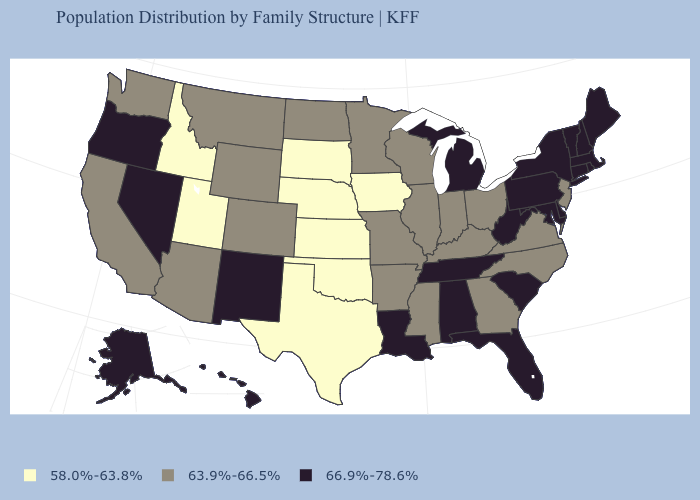Does New Hampshire have a higher value than North Carolina?
Keep it brief. Yes. Which states have the lowest value in the West?
Quick response, please. Idaho, Utah. What is the value of Utah?
Keep it brief. 58.0%-63.8%. What is the value of Maryland?
Write a very short answer. 66.9%-78.6%. What is the value of Arizona?
Write a very short answer. 63.9%-66.5%. Does Florida have the same value as Rhode Island?
Concise answer only. Yes. What is the value of Texas?
Keep it brief. 58.0%-63.8%. Does the first symbol in the legend represent the smallest category?
Short answer required. Yes. What is the highest value in the USA?
Be succinct. 66.9%-78.6%. Which states have the lowest value in the South?
Be succinct. Oklahoma, Texas. What is the lowest value in the Northeast?
Short answer required. 63.9%-66.5%. Does the first symbol in the legend represent the smallest category?
Be succinct. Yes. Name the states that have a value in the range 66.9%-78.6%?
Answer briefly. Alabama, Alaska, Connecticut, Delaware, Florida, Hawaii, Louisiana, Maine, Maryland, Massachusetts, Michigan, Nevada, New Hampshire, New Mexico, New York, Oregon, Pennsylvania, Rhode Island, South Carolina, Tennessee, Vermont, West Virginia. Which states have the highest value in the USA?
Give a very brief answer. Alabama, Alaska, Connecticut, Delaware, Florida, Hawaii, Louisiana, Maine, Maryland, Massachusetts, Michigan, Nevada, New Hampshire, New Mexico, New York, Oregon, Pennsylvania, Rhode Island, South Carolina, Tennessee, Vermont, West Virginia. Among the states that border Louisiana , does Texas have the lowest value?
Quick response, please. Yes. 